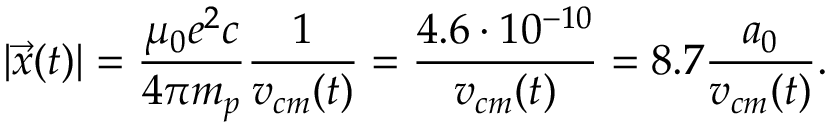Convert formula to latex. <formula><loc_0><loc_0><loc_500><loc_500>| \vec { x } ( t ) | = \frac { \mu _ { 0 } e ^ { 2 } c } { 4 \pi m _ { p } } \frac { 1 } { v _ { c m } ( t ) } = \frac { 4 . 6 \cdot 1 0 ^ { - 1 0 } } { v _ { c m } ( t ) } = 8 . 7 \frac { a _ { 0 } } { v _ { c m } ( t ) } .</formula> 